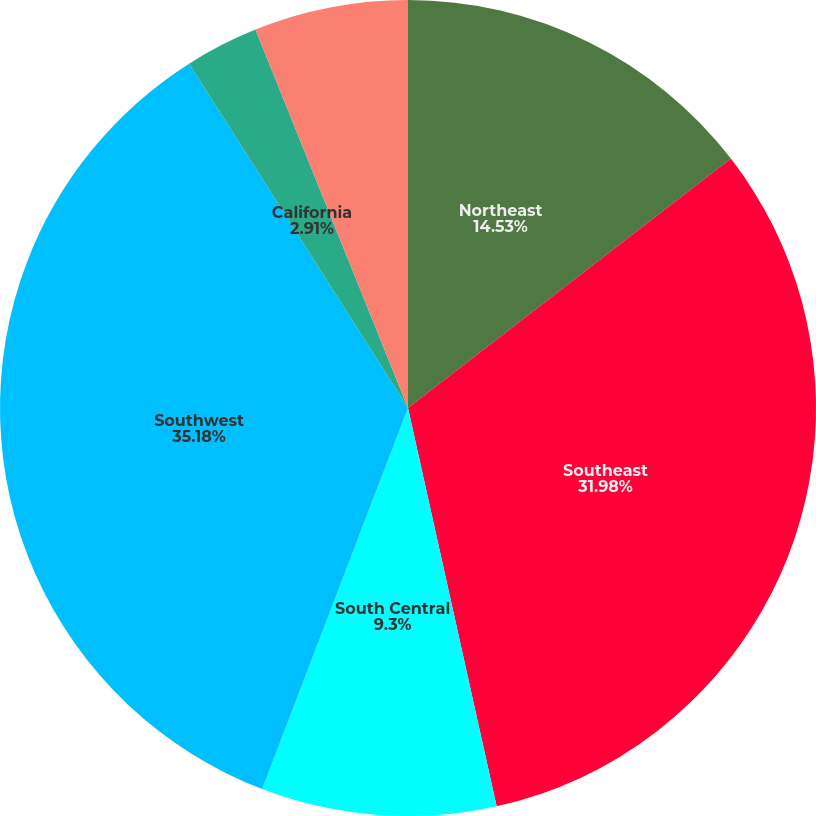Convert chart to OTSL. <chart><loc_0><loc_0><loc_500><loc_500><pie_chart><fcel>Northeast<fcel>Southeast<fcel>South Central<fcel>Southwest<fcel>California<fcel>West<nl><fcel>14.53%<fcel>31.98%<fcel>9.3%<fcel>35.17%<fcel>2.91%<fcel>6.1%<nl></chart> 